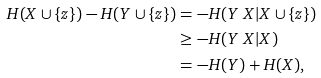Convert formula to latex. <formula><loc_0><loc_0><loc_500><loc_500>H ( X \cup \{ z \} ) - H ( Y \cup \{ z \} ) & = - H ( Y \ X | X \cup \{ z \} ) \\ & \geq - H ( Y \ X | X ) \\ & = - H ( Y ) + H ( X ) ,</formula> 